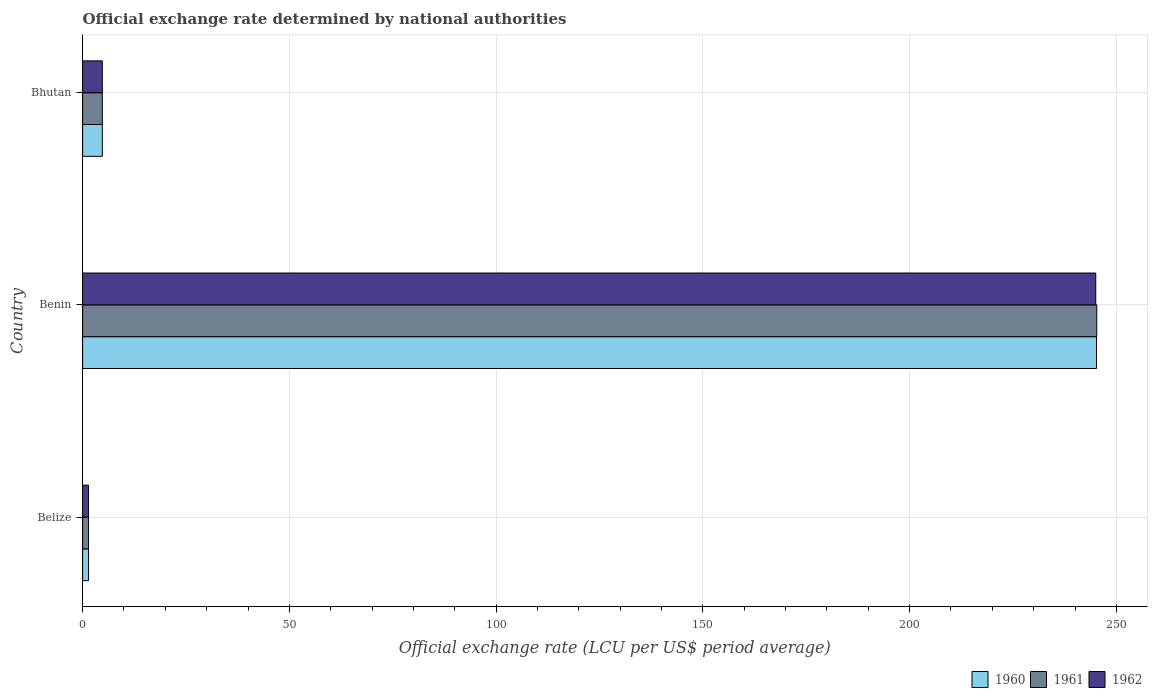How many different coloured bars are there?
Give a very brief answer. 3. Are the number of bars per tick equal to the number of legend labels?
Provide a succinct answer. Yes. How many bars are there on the 2nd tick from the top?
Offer a very short reply. 3. How many bars are there on the 1st tick from the bottom?
Provide a short and direct response. 3. What is the label of the 1st group of bars from the top?
Provide a succinct answer. Bhutan. What is the official exchange rate in 1962 in Bhutan?
Make the answer very short. 4.76. Across all countries, what is the maximum official exchange rate in 1962?
Offer a terse response. 245.01. Across all countries, what is the minimum official exchange rate in 1960?
Your answer should be very brief. 1.43. In which country was the official exchange rate in 1960 maximum?
Ensure brevity in your answer.  Benin. In which country was the official exchange rate in 1962 minimum?
Ensure brevity in your answer.  Belize. What is the total official exchange rate in 1961 in the graph?
Provide a succinct answer. 251.45. What is the difference between the official exchange rate in 1960 in Belize and that in Benin?
Provide a short and direct response. -243.77. What is the difference between the official exchange rate in 1960 in Bhutan and the official exchange rate in 1962 in Benin?
Keep it short and to the point. -240.25. What is the average official exchange rate in 1962 per country?
Your answer should be very brief. 83.73. What is the difference between the official exchange rate in 1960 and official exchange rate in 1962 in Benin?
Give a very brief answer. 0.18. What is the ratio of the official exchange rate in 1961 in Benin to that in Bhutan?
Offer a very short reply. 51.5. What is the difference between the highest and the second highest official exchange rate in 1960?
Ensure brevity in your answer.  240.43. What is the difference between the highest and the lowest official exchange rate in 1961?
Your answer should be very brief. 243.83. In how many countries, is the official exchange rate in 1960 greater than the average official exchange rate in 1960 taken over all countries?
Offer a very short reply. 1. Is the sum of the official exchange rate in 1961 in Belize and Bhutan greater than the maximum official exchange rate in 1962 across all countries?
Your answer should be compact. No. What does the 3rd bar from the top in Belize represents?
Your answer should be very brief. 1960. Is it the case that in every country, the sum of the official exchange rate in 1961 and official exchange rate in 1960 is greater than the official exchange rate in 1962?
Offer a very short reply. Yes. Are all the bars in the graph horizontal?
Make the answer very short. Yes. How many countries are there in the graph?
Make the answer very short. 3. Does the graph contain any zero values?
Provide a short and direct response. No. Where does the legend appear in the graph?
Make the answer very short. Bottom right. How are the legend labels stacked?
Offer a terse response. Horizontal. What is the title of the graph?
Your answer should be very brief. Official exchange rate determined by national authorities. What is the label or title of the X-axis?
Ensure brevity in your answer.  Official exchange rate (LCU per US$ period average). What is the Official exchange rate (LCU per US$ period average) of 1960 in Belize?
Ensure brevity in your answer.  1.43. What is the Official exchange rate (LCU per US$ period average) in 1961 in Belize?
Provide a short and direct response. 1.43. What is the Official exchange rate (LCU per US$ period average) of 1962 in Belize?
Provide a short and direct response. 1.43. What is the Official exchange rate (LCU per US$ period average) of 1960 in Benin?
Your answer should be compact. 245.2. What is the Official exchange rate (LCU per US$ period average) of 1961 in Benin?
Ensure brevity in your answer.  245.26. What is the Official exchange rate (LCU per US$ period average) of 1962 in Benin?
Give a very brief answer. 245.01. What is the Official exchange rate (LCU per US$ period average) in 1960 in Bhutan?
Provide a short and direct response. 4.76. What is the Official exchange rate (LCU per US$ period average) in 1961 in Bhutan?
Your answer should be compact. 4.76. What is the Official exchange rate (LCU per US$ period average) of 1962 in Bhutan?
Offer a terse response. 4.76. Across all countries, what is the maximum Official exchange rate (LCU per US$ period average) of 1960?
Your answer should be compact. 245.2. Across all countries, what is the maximum Official exchange rate (LCU per US$ period average) of 1961?
Provide a succinct answer. 245.26. Across all countries, what is the maximum Official exchange rate (LCU per US$ period average) in 1962?
Provide a succinct answer. 245.01. Across all countries, what is the minimum Official exchange rate (LCU per US$ period average) of 1960?
Provide a succinct answer. 1.43. Across all countries, what is the minimum Official exchange rate (LCU per US$ period average) in 1961?
Provide a succinct answer. 1.43. Across all countries, what is the minimum Official exchange rate (LCU per US$ period average) in 1962?
Make the answer very short. 1.43. What is the total Official exchange rate (LCU per US$ period average) of 1960 in the graph?
Give a very brief answer. 251.39. What is the total Official exchange rate (LCU per US$ period average) in 1961 in the graph?
Offer a very short reply. 251.45. What is the total Official exchange rate (LCU per US$ period average) of 1962 in the graph?
Offer a very short reply. 251.2. What is the difference between the Official exchange rate (LCU per US$ period average) of 1960 in Belize and that in Benin?
Provide a short and direct response. -243.77. What is the difference between the Official exchange rate (LCU per US$ period average) of 1961 in Belize and that in Benin?
Your answer should be very brief. -243.83. What is the difference between the Official exchange rate (LCU per US$ period average) in 1962 in Belize and that in Benin?
Provide a short and direct response. -243.59. What is the difference between the Official exchange rate (LCU per US$ period average) of 1961 in Belize and that in Bhutan?
Your response must be concise. -3.33. What is the difference between the Official exchange rate (LCU per US$ period average) in 1962 in Belize and that in Bhutan?
Ensure brevity in your answer.  -3.33. What is the difference between the Official exchange rate (LCU per US$ period average) of 1960 in Benin and that in Bhutan?
Give a very brief answer. 240.43. What is the difference between the Official exchange rate (LCU per US$ period average) in 1961 in Benin and that in Bhutan?
Your answer should be compact. 240.5. What is the difference between the Official exchange rate (LCU per US$ period average) in 1962 in Benin and that in Bhutan?
Provide a succinct answer. 240.25. What is the difference between the Official exchange rate (LCU per US$ period average) in 1960 in Belize and the Official exchange rate (LCU per US$ period average) in 1961 in Benin?
Make the answer very short. -243.83. What is the difference between the Official exchange rate (LCU per US$ period average) of 1960 in Belize and the Official exchange rate (LCU per US$ period average) of 1962 in Benin?
Provide a short and direct response. -243.59. What is the difference between the Official exchange rate (LCU per US$ period average) of 1961 in Belize and the Official exchange rate (LCU per US$ period average) of 1962 in Benin?
Ensure brevity in your answer.  -243.59. What is the difference between the Official exchange rate (LCU per US$ period average) in 1960 in Belize and the Official exchange rate (LCU per US$ period average) in 1961 in Bhutan?
Your answer should be compact. -3.33. What is the difference between the Official exchange rate (LCU per US$ period average) in 1961 in Belize and the Official exchange rate (LCU per US$ period average) in 1962 in Bhutan?
Ensure brevity in your answer.  -3.33. What is the difference between the Official exchange rate (LCU per US$ period average) in 1960 in Benin and the Official exchange rate (LCU per US$ period average) in 1961 in Bhutan?
Provide a succinct answer. 240.43. What is the difference between the Official exchange rate (LCU per US$ period average) in 1960 in Benin and the Official exchange rate (LCU per US$ period average) in 1962 in Bhutan?
Offer a very short reply. 240.43. What is the difference between the Official exchange rate (LCU per US$ period average) in 1961 in Benin and the Official exchange rate (LCU per US$ period average) in 1962 in Bhutan?
Your answer should be compact. 240.5. What is the average Official exchange rate (LCU per US$ period average) of 1960 per country?
Offer a very short reply. 83.8. What is the average Official exchange rate (LCU per US$ period average) of 1961 per country?
Your answer should be compact. 83.82. What is the average Official exchange rate (LCU per US$ period average) in 1962 per country?
Ensure brevity in your answer.  83.73. What is the difference between the Official exchange rate (LCU per US$ period average) in 1960 and Official exchange rate (LCU per US$ period average) in 1961 in Belize?
Your response must be concise. 0. What is the difference between the Official exchange rate (LCU per US$ period average) of 1961 and Official exchange rate (LCU per US$ period average) of 1962 in Belize?
Provide a succinct answer. 0. What is the difference between the Official exchange rate (LCU per US$ period average) of 1960 and Official exchange rate (LCU per US$ period average) of 1961 in Benin?
Give a very brief answer. -0.07. What is the difference between the Official exchange rate (LCU per US$ period average) of 1960 and Official exchange rate (LCU per US$ period average) of 1962 in Benin?
Give a very brief answer. 0.18. What is the difference between the Official exchange rate (LCU per US$ period average) of 1961 and Official exchange rate (LCU per US$ period average) of 1962 in Benin?
Ensure brevity in your answer.  0.25. What is the difference between the Official exchange rate (LCU per US$ period average) in 1960 and Official exchange rate (LCU per US$ period average) in 1962 in Bhutan?
Your response must be concise. 0. What is the ratio of the Official exchange rate (LCU per US$ period average) in 1960 in Belize to that in Benin?
Your response must be concise. 0.01. What is the ratio of the Official exchange rate (LCU per US$ period average) of 1961 in Belize to that in Benin?
Make the answer very short. 0.01. What is the ratio of the Official exchange rate (LCU per US$ period average) in 1962 in Belize to that in Benin?
Your answer should be compact. 0.01. What is the ratio of the Official exchange rate (LCU per US$ period average) of 1960 in Belize to that in Bhutan?
Offer a terse response. 0.3. What is the ratio of the Official exchange rate (LCU per US$ period average) of 1961 in Belize to that in Bhutan?
Offer a very short reply. 0.3. What is the ratio of the Official exchange rate (LCU per US$ period average) in 1962 in Belize to that in Bhutan?
Provide a short and direct response. 0.3. What is the ratio of the Official exchange rate (LCU per US$ period average) in 1960 in Benin to that in Bhutan?
Ensure brevity in your answer.  51.49. What is the ratio of the Official exchange rate (LCU per US$ period average) of 1961 in Benin to that in Bhutan?
Keep it short and to the point. 51.5. What is the ratio of the Official exchange rate (LCU per US$ period average) of 1962 in Benin to that in Bhutan?
Offer a terse response. 51.45. What is the difference between the highest and the second highest Official exchange rate (LCU per US$ period average) of 1960?
Give a very brief answer. 240.43. What is the difference between the highest and the second highest Official exchange rate (LCU per US$ period average) of 1961?
Your answer should be very brief. 240.5. What is the difference between the highest and the second highest Official exchange rate (LCU per US$ period average) in 1962?
Your answer should be very brief. 240.25. What is the difference between the highest and the lowest Official exchange rate (LCU per US$ period average) in 1960?
Offer a very short reply. 243.77. What is the difference between the highest and the lowest Official exchange rate (LCU per US$ period average) of 1961?
Your answer should be compact. 243.83. What is the difference between the highest and the lowest Official exchange rate (LCU per US$ period average) in 1962?
Ensure brevity in your answer.  243.59. 